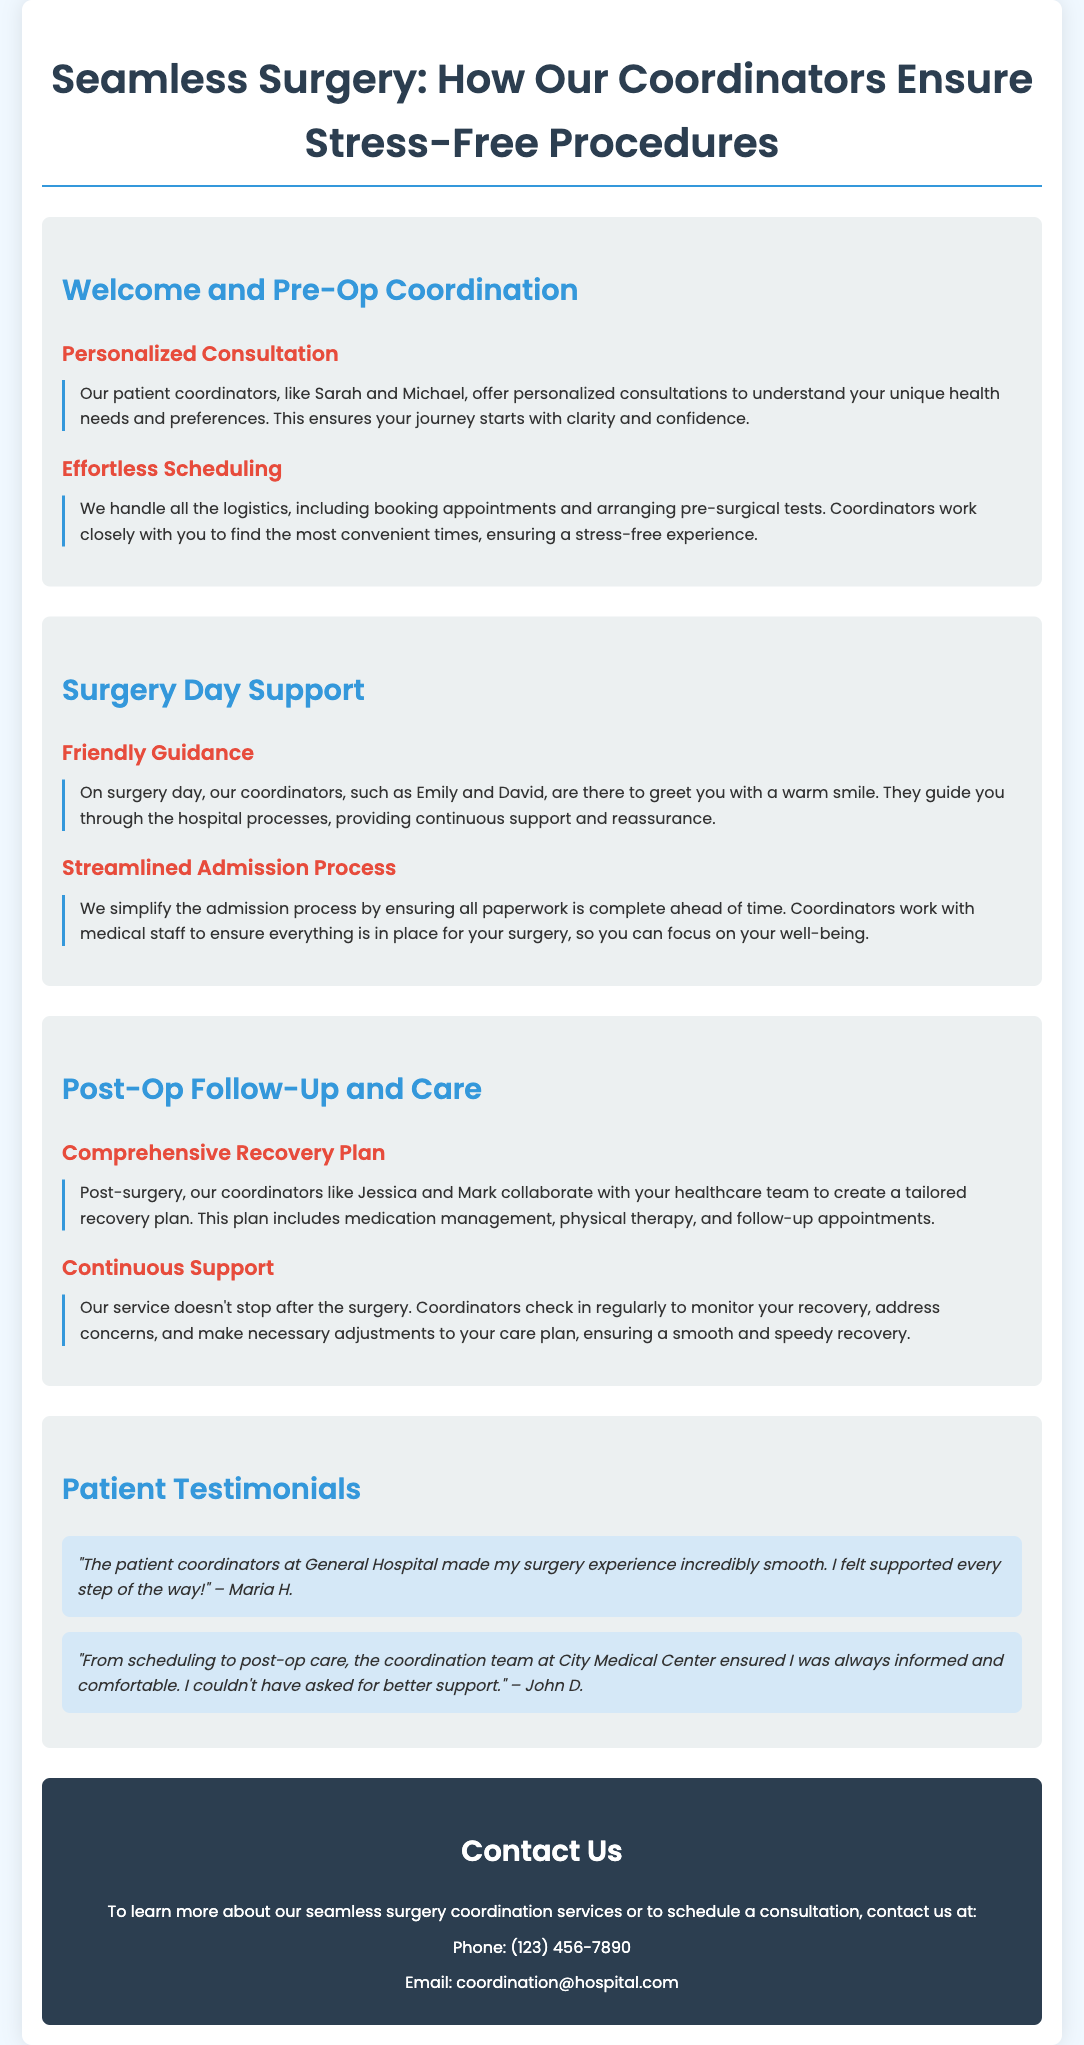What is the title of the flyer? The title of the flyer is clearly presented at the top of the document.
Answer: Seamless Surgery: How Our Coordinators Ensure Stress-Free Procedures Who is mentioned as one of the coordinators in the Pre-Op Coordination section? The document lists specific coordinators in various sections, including their names in the Pre-Op section.
Answer: Sarah What does the surgery day support include? The document outlines various support features offered on surgery day, including specific services provided by the coordinators.
Answer: Friendly Guidance How do coordinators simplify the admission process? The document specifies that coordinators prepare paperwork in advance to help with the admission process.
Answer: All paperwork is complete ahead of time What is a key aspect of the post-op follow-up care? The document discusses the comprehensive care provided after surgery, highlighting important components of recovery management.
Answer: Tailored recovery plan How do coordinators check on recovery? The flyer details how coordinators maintain contact with patients after surgery to ensure recovery is on track.
Answer: Regularly check in What kind of testimonials does the document include? The document features reviews from patients about their experiences with the coordinators.
Answer: Patient Testimonials What is the contact email for more information? The flyer contains a specific contact email for inquiries about the services provided by the coordinators.
Answer: coordination@hospital.com 